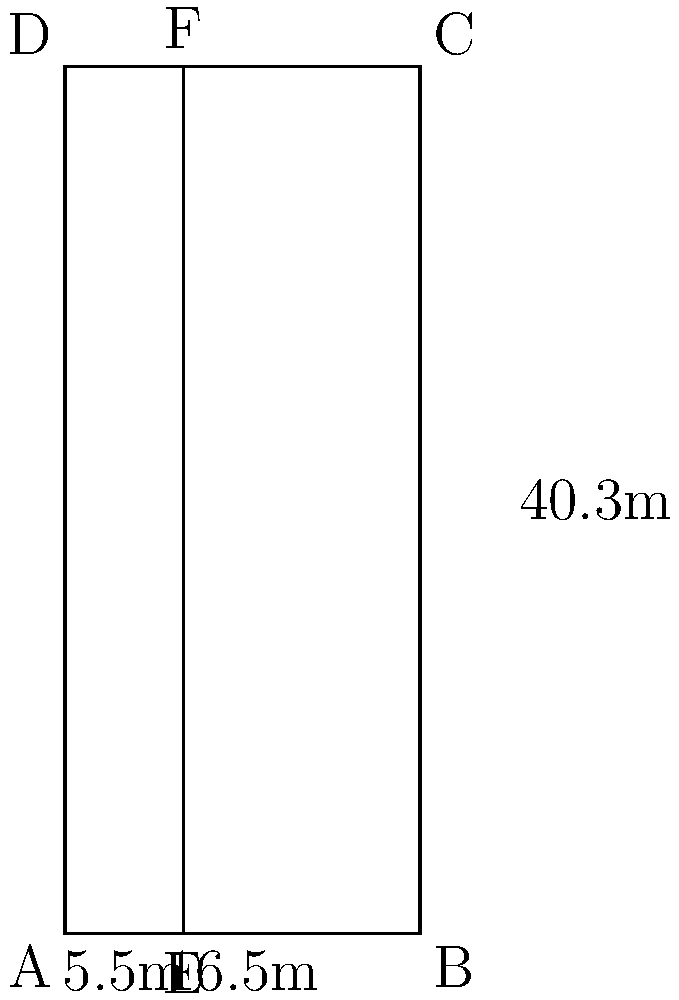In a standard soccer field, the penalty area is a rectangular region in front of each goal. Given that the width of the penalty area is 16.5 meters and its depth (distance from the goal line) is 5.5 meters, what is the area of the shaded region ADEF in square meters? To find the area of the shaded region ADEF, we need to follow these steps:

1) First, we need to identify the shape of ADEF. It's a rectangle.

2) To calculate the area of a rectangle, we use the formula:
   Area = length × width

3) From the diagram, we can see that:
   - The width of ADEF is the same as the depth of the penalty area, which is 5.5 meters.
   - The length of ADEF is the full height of the penalty area, which is 40.3 meters.

4) Now, let's plug these values into our formula:
   Area = 40.3 m × 5.5 m

5) Calculating this:
   Area = 221.65 m²

Therefore, the area of the shaded region ADEF is 221.65 square meters.
Answer: 221.65 m² 